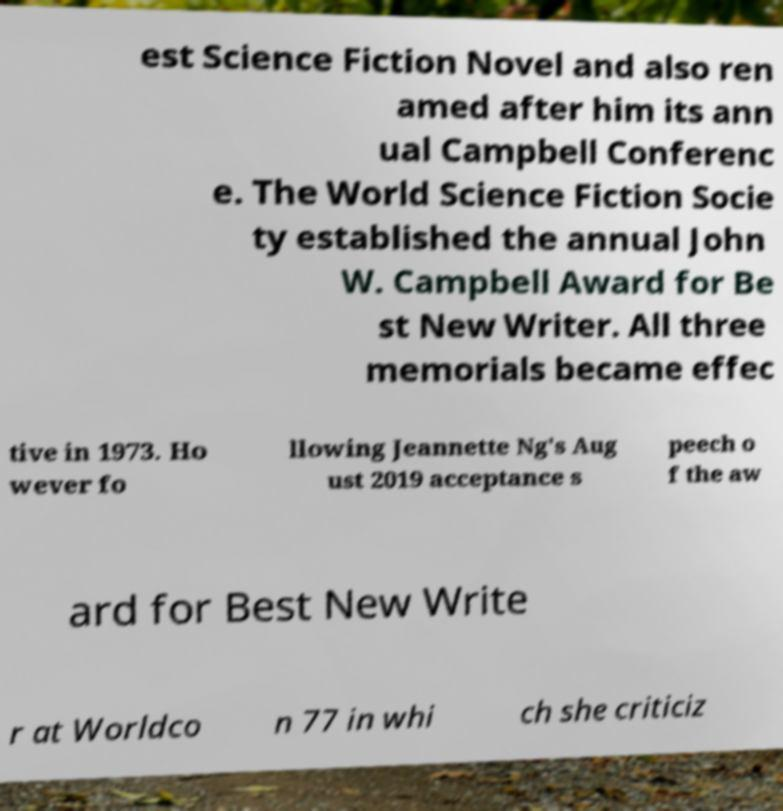Could you assist in decoding the text presented in this image and type it out clearly? est Science Fiction Novel and also ren amed after him its ann ual Campbell Conferenc e. The World Science Fiction Socie ty established the annual John W. Campbell Award for Be st New Writer. All three memorials became effec tive in 1973. Ho wever fo llowing Jeannette Ng's Aug ust 2019 acceptance s peech o f the aw ard for Best New Write r at Worldco n 77 in whi ch she criticiz 